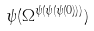Convert formula to latex. <formula><loc_0><loc_0><loc_500><loc_500>\psi ( \Omega ^ { \psi ( \psi ( \psi ( 0 ) ) ) } )</formula> 